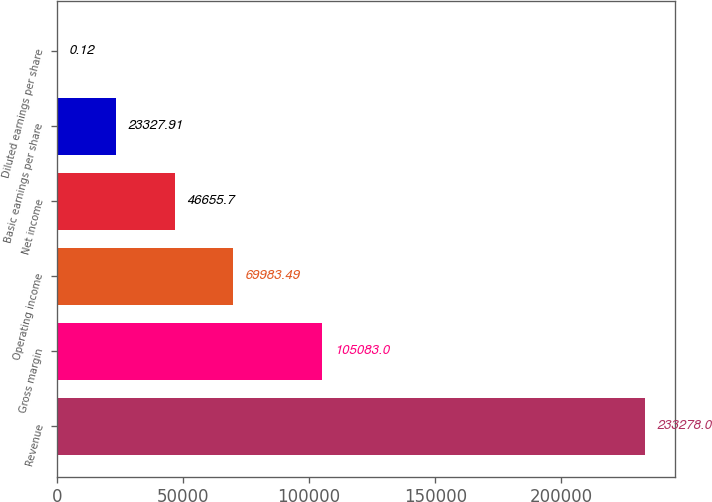Convert chart. <chart><loc_0><loc_0><loc_500><loc_500><bar_chart><fcel>Revenue<fcel>Gross margin<fcel>Operating income<fcel>Net income<fcel>Basic earnings per share<fcel>Diluted earnings per share<nl><fcel>233278<fcel>105083<fcel>69983.5<fcel>46655.7<fcel>23327.9<fcel>0.12<nl></chart> 